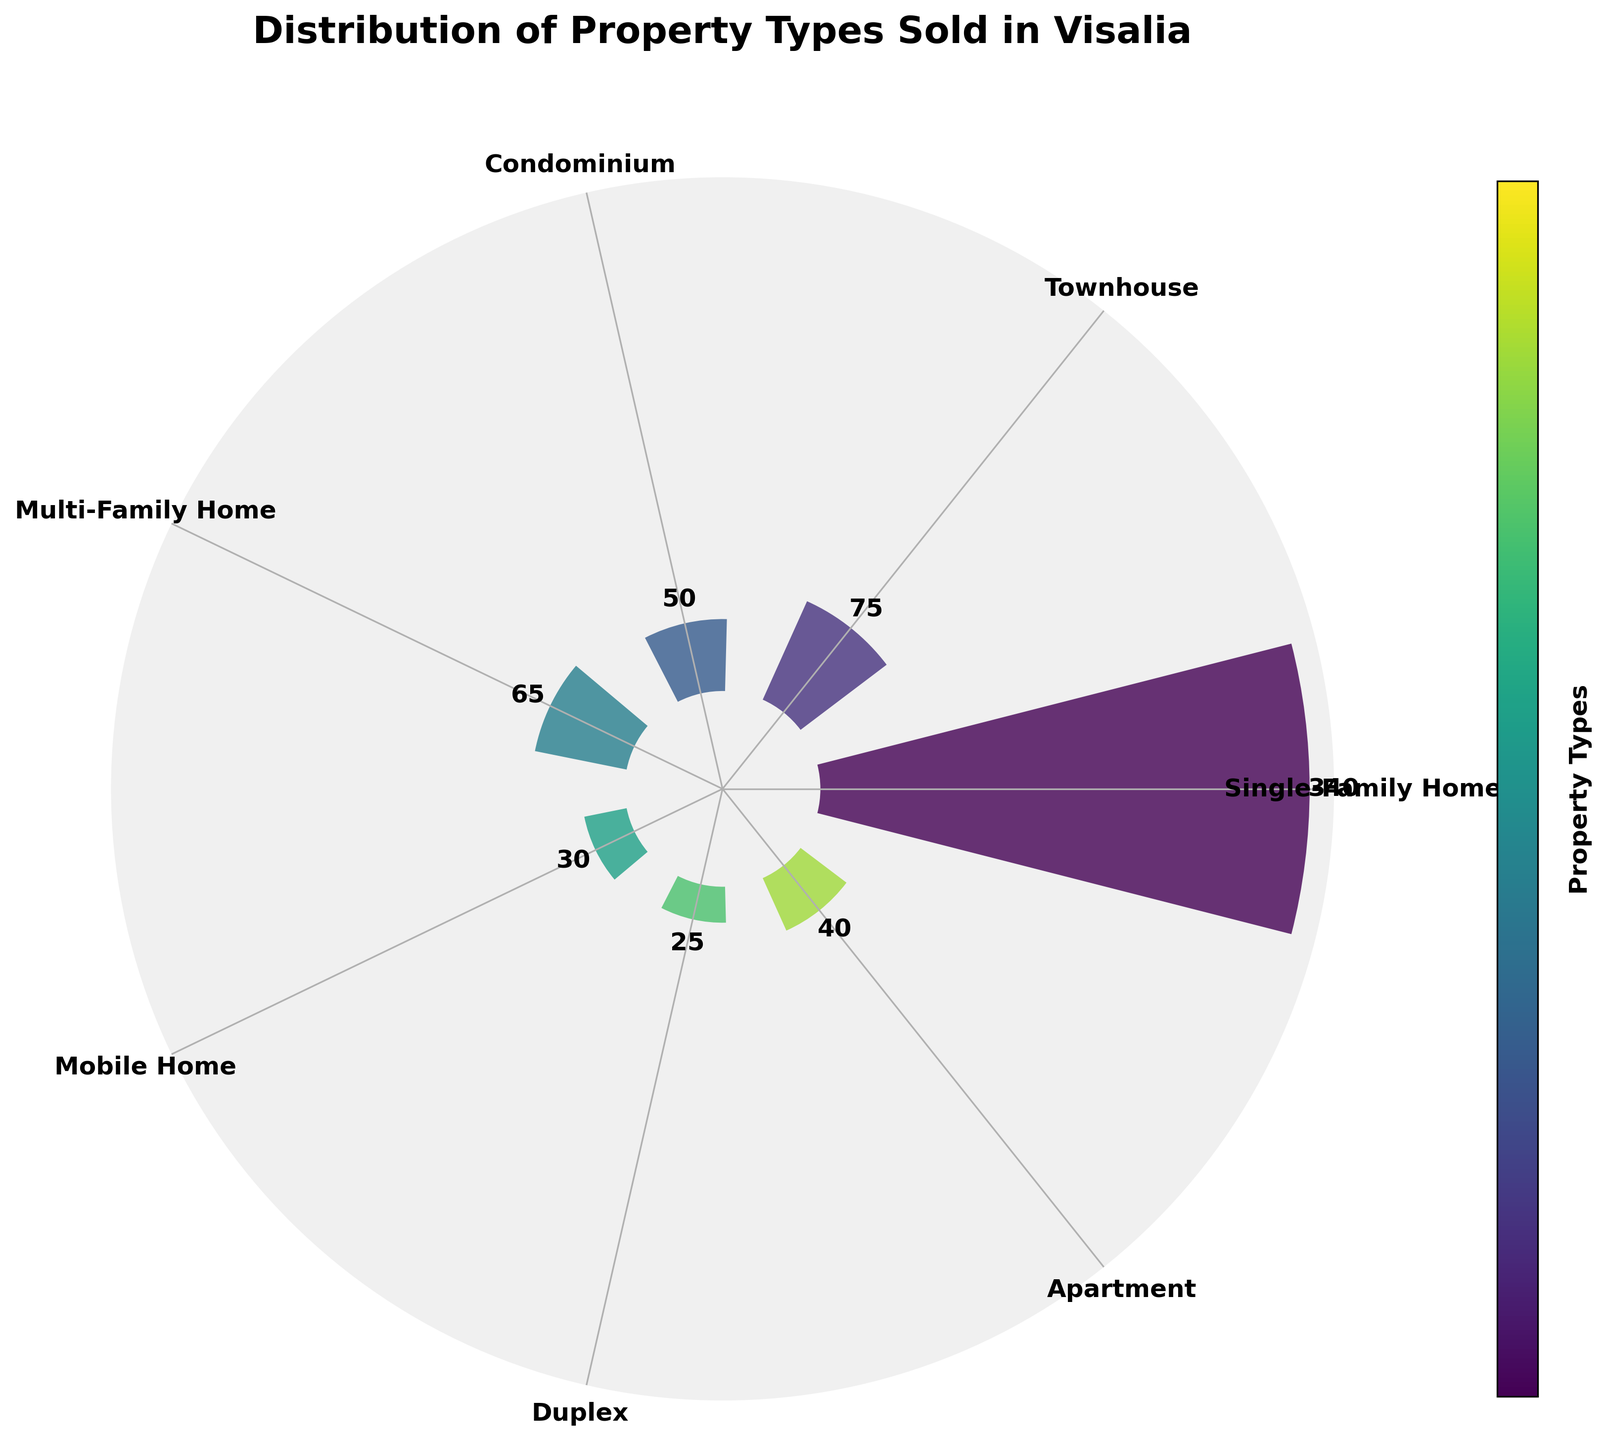What's the most common property type sold in Visalia? The most common property type can be identified by the bar with the highest count on the rose chart. The title informs that the chart represents properties sold in Visalia. The largest bar corresponds to Single-Family Homes, indicated visually by its length and the count label.
Answer: Single-Family Home How many townhouses were sold in the past year? Locate the section of the rose chart labeled 'Townhouse' and read the count label attached to its bar.
Answer: 75 Compare the number of Multi-Family Homes and Condominiums sold. Which one had more sales? Locate the bars labeled 'Multi-Family Home' and 'Condominium'. Compare their count labels to determine which is larger. Multi-Family Home is 65, and Condominium is 50.
Answer: Multi-Family Home What is the combined total sales of Mobile Homes and Duplexes? Find the counts for Mobile Home and Duplex: 30 and 25, respectively. Add them together: 30 + 25 = 55.
Answer: 55 What is the angle difference between the bars for Single-Family Homes and Apartments? There are 7 property types equally spaced in a circular plot. Divide 360° by 7 to find the angle per segment: approximately 51.43°. Single-Family Homes and Apartments are separated by four segments, so multiply 51.43° by 4.
Answer: 205.72° Which property type has the least sales, and how many units were sold? The shortest bar on the rose chart represents the property type with the least sales. Identify its label ('Duplex') and refer to its count label for the number of sales.
Answer: Duplex, 25 How does the number of condos sold compare to the number of mobile homes sold? Identify the count labels for Condominium and Mobile Home: 50 and 30 respectively. Condominiums have a higher count.
Answer: Condominiums sold more What is the total number of properties sold across all types? Add the counts of all property types: 340 + 75 + 50 + 65 + 30 + 25 + 40 = 625.
Answer: 625 Which property type is represented by the lightest color on the chart? The bar with the lightest color based on the colormap transition from dark to light corresponds to the property type 'Single-Family Home'.
Answer: Single-Family Home 